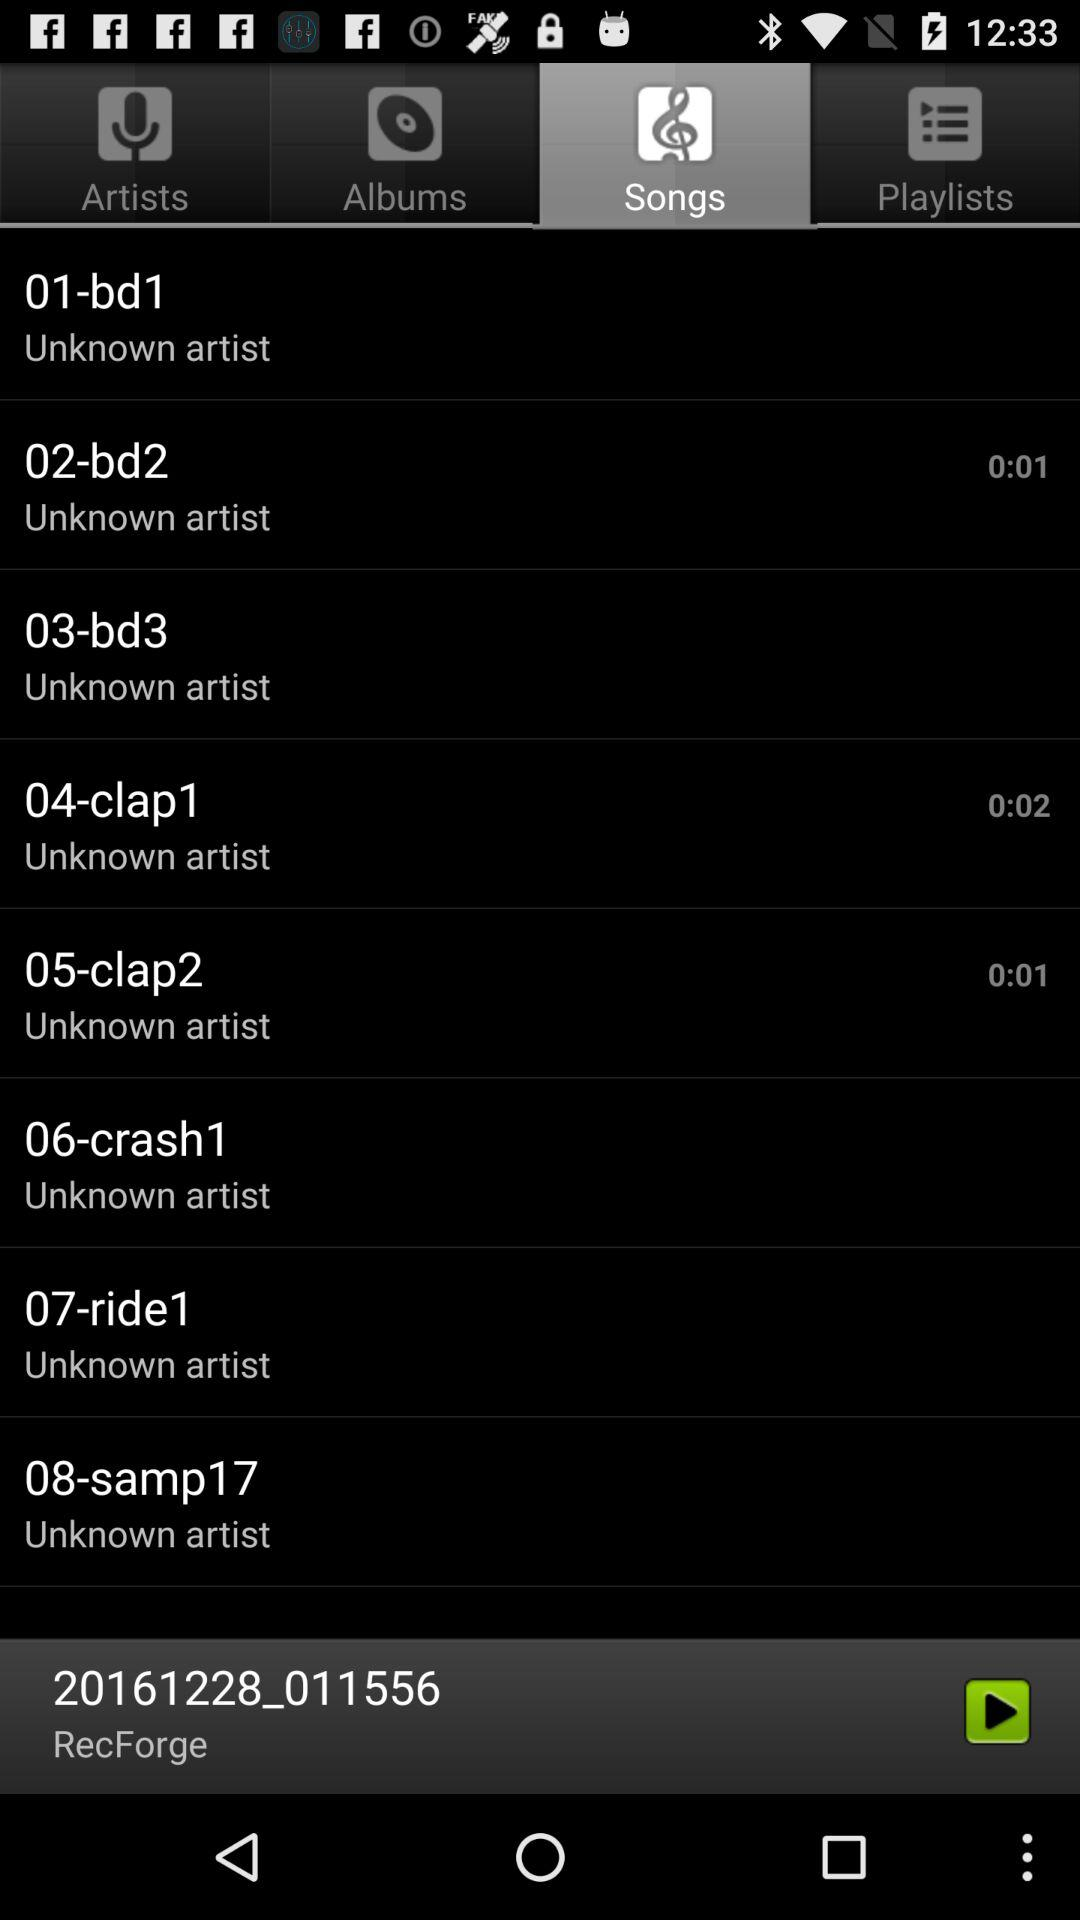What song was last played? The song "20161228_011556" was last played. 